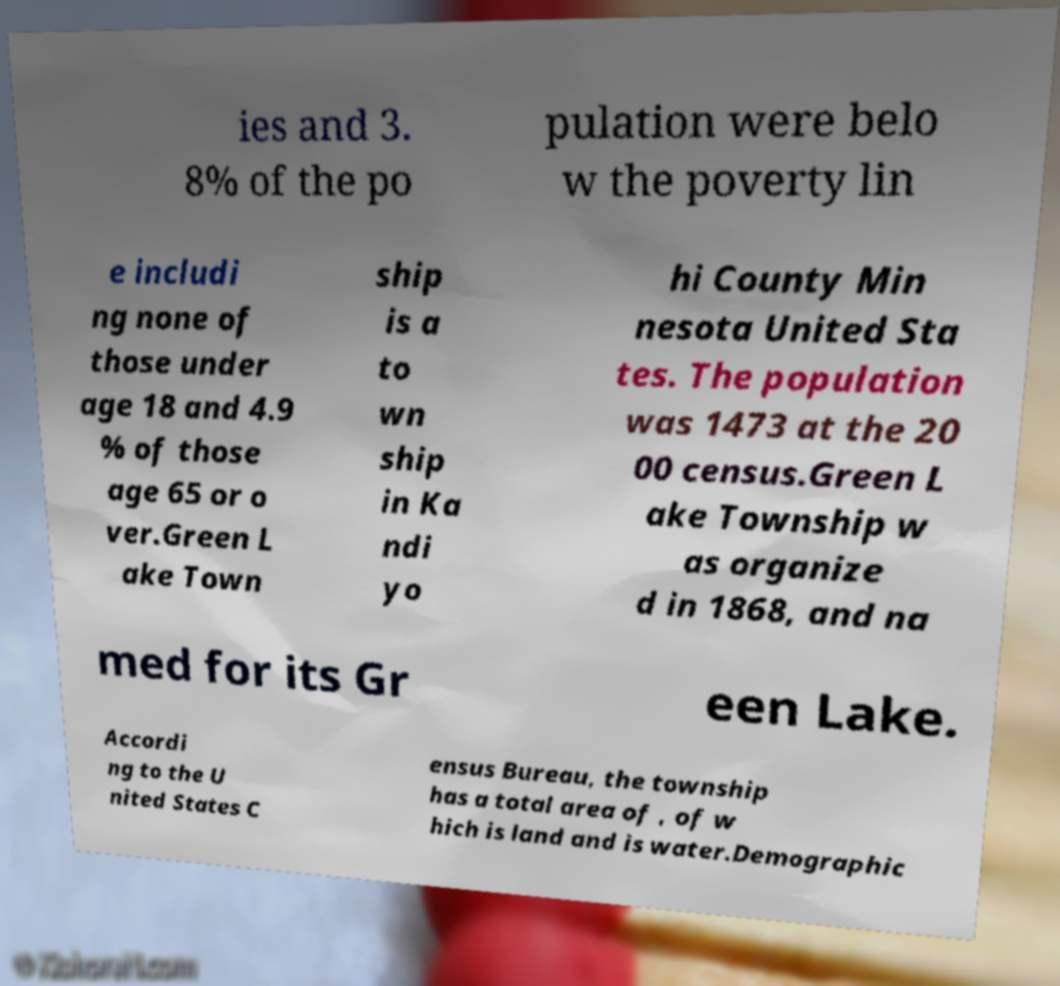Please identify and transcribe the text found in this image. ies and 3. 8% of the po pulation were belo w the poverty lin e includi ng none of those under age 18 and 4.9 % of those age 65 or o ver.Green L ake Town ship is a to wn ship in Ka ndi yo hi County Min nesota United Sta tes. The population was 1473 at the 20 00 census.Green L ake Township w as organize d in 1868, and na med for its Gr een Lake. Accordi ng to the U nited States C ensus Bureau, the township has a total area of , of w hich is land and is water.Demographic 